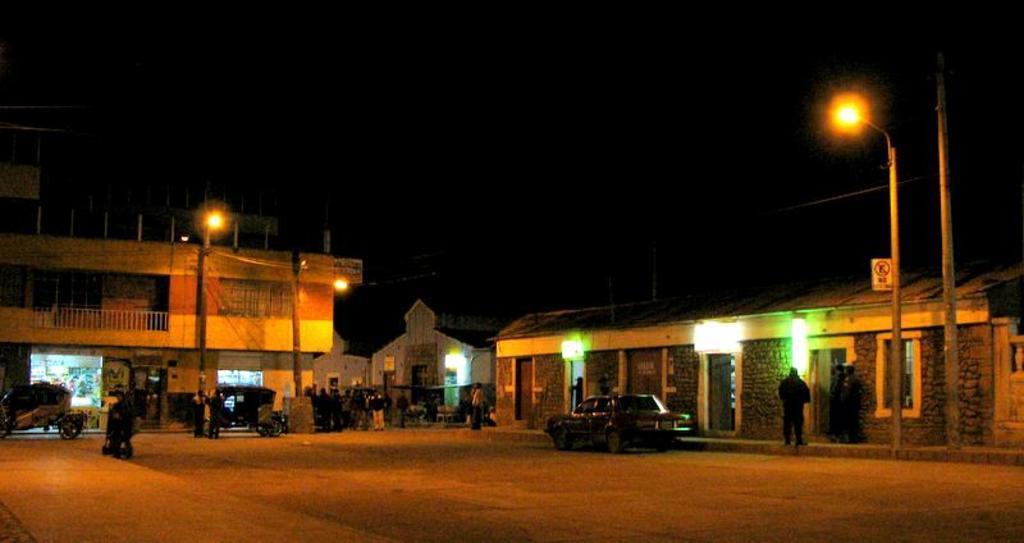How would you summarize this image in a sentence or two? In this picture we can see group of people and vehicles, and also we can see few poles, lights and buildings. 